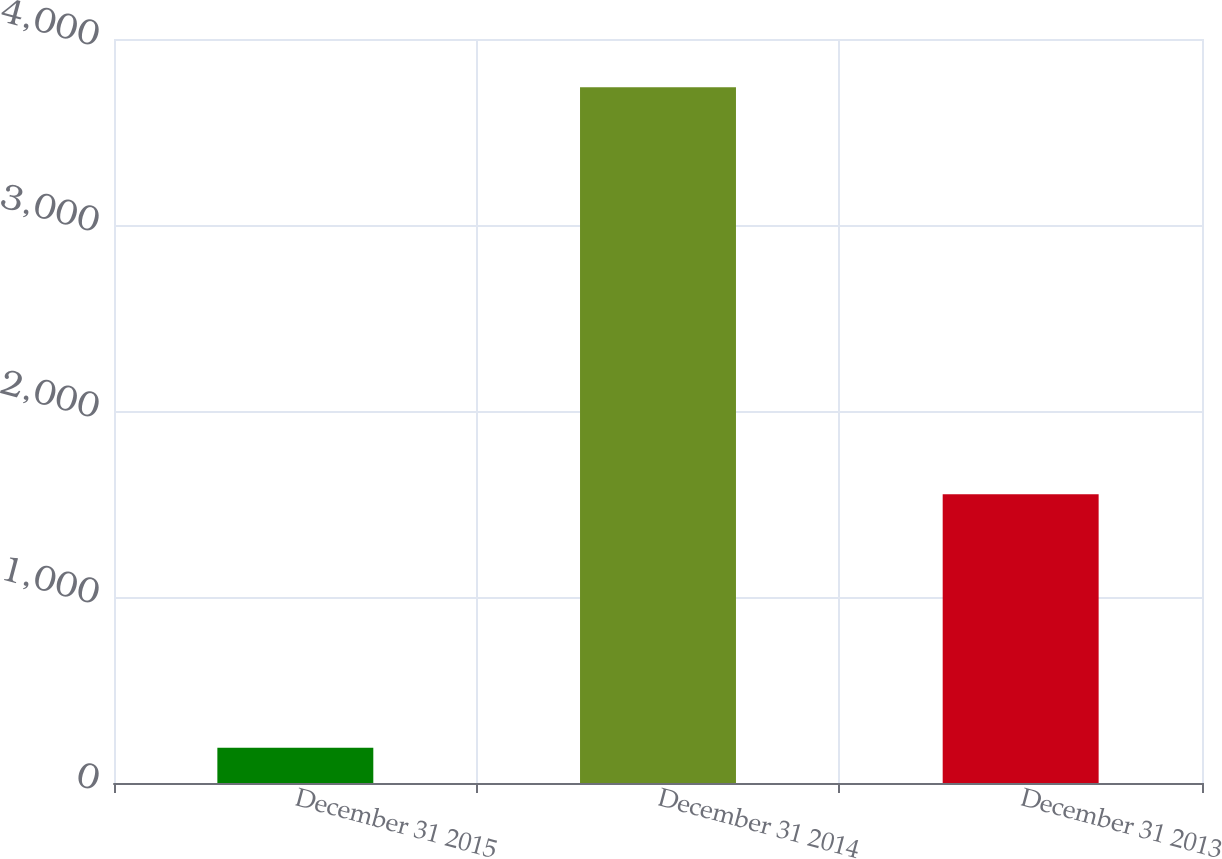Convert chart. <chart><loc_0><loc_0><loc_500><loc_500><bar_chart><fcel>December 31 2015<fcel>December 31 2014<fcel>December 31 2013<nl><fcel>190<fcel>3741<fcel>1553<nl></chart> 